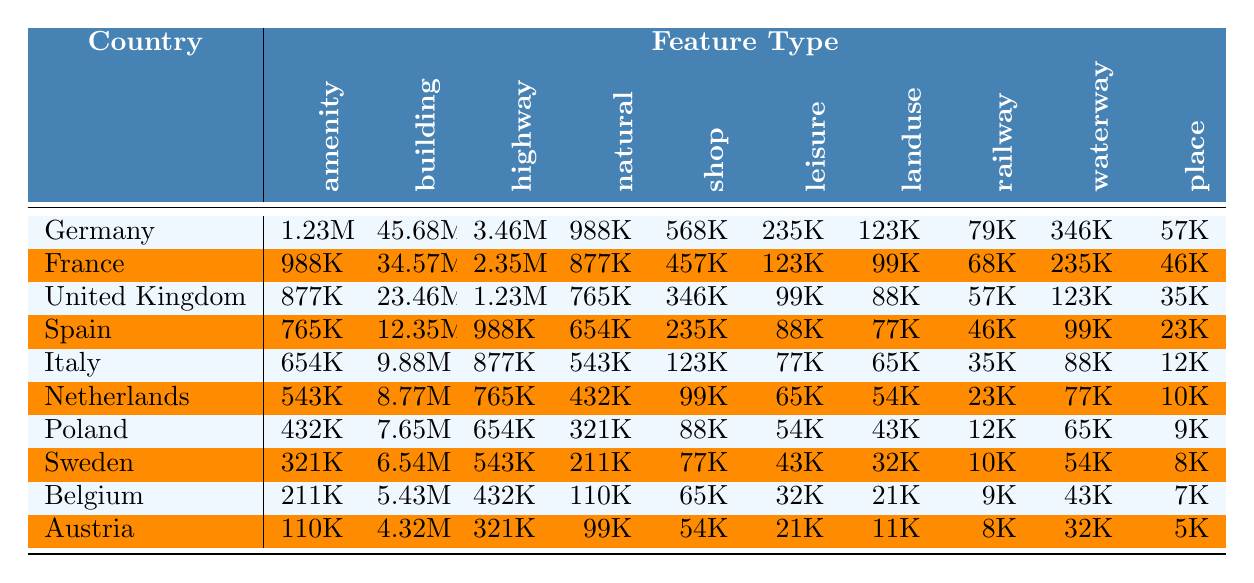What is the total number of amenities in Germany? According to the table, the number of amenities in Germany is 1,234,567.
Answer: 1,234,567 Which country has the highest count of buildings? The table shows that Germany has 45,678,901 buildings, which is the highest count among the listed countries.
Answer: Germany What is the average number of shops across all countries? To find the average number of shops, sum the shop counts: 567,890 + 456,789 + 345,678 + 234,567 + 123,456 + 98,765 + 87,654 + 76,543 + 65,432 + 54,321 = 2,133,715. There are 10 countries, so the average is 2,133,715 / 10 = 213,371.5.
Answer: 213,371.5 Does Poland have more highways than Italy? The table shows that Poland has 654,321 highways while Italy has 876,543. Therefore, it is false that Poland has more highways than Italy.
Answer: No Which country has the least number of places? Looking at the table, Austria has the least number of places with a count of 5,432.
Answer: Austria What is the difference in the number of natural features between Germany and Sweden? Germany has 987,654 natural features, while Sweden has 210,987. The difference is 987,654 - 210,987 = 776,667.
Answer: 776,667 Is the total number of leisure features in France greater than that in Italy? France has 123,456 leisure features and Italy has 76,543. Since 123,456 is greater than 76,543, the statement is true.
Answer: Yes What is the total number of amenities, building, and highway features in the United Kingdom? The United Kingdom has 876,543 amenities, 23,456,789 buildings, and 1,234,567 highways. The total is 876,543 + 23,456,789 + 1,234,567 = 25,567,899.
Answer: 25,567,899 Which country has a higher count of waterways: Belgium or the Netherlands? Belgium has 43,210 waterways while the Netherlands has 76,543. Since 76,543 is greater than 43,210, the Netherlands has a higher count.
Answer: Netherlands What percentage of the total buildings in all countries are in France? The total number of buildings is the sum of buildings in each country. France has 34,567,890 buildings. The total is 45,678,901 + 34,567,890 + 23,456,789 + 12,345,678 + 9,876,543 + 8,765,432 + 7,654,321 + 6,543,210 + 5,432,109 + 4,321,098 =  418,674,970. The percentage is (34,567,890 / 418,674,970) * 100 = approximately 8.25%.
Answer: 8.25% 